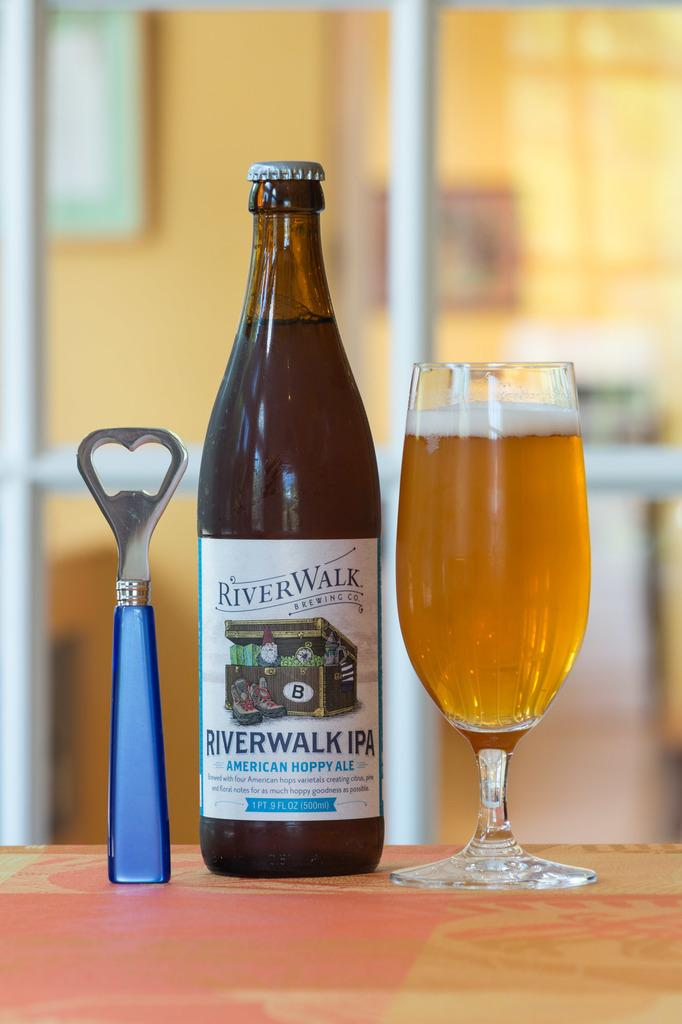<image>
Relay a brief, clear account of the picture shown. Bottle of River Walk IPA beer next to a can opener and a cup of beer. 